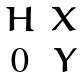<formula> <loc_0><loc_0><loc_500><loc_500>\begin{matrix} H & X \\ 0 & Y \end{matrix}</formula> 